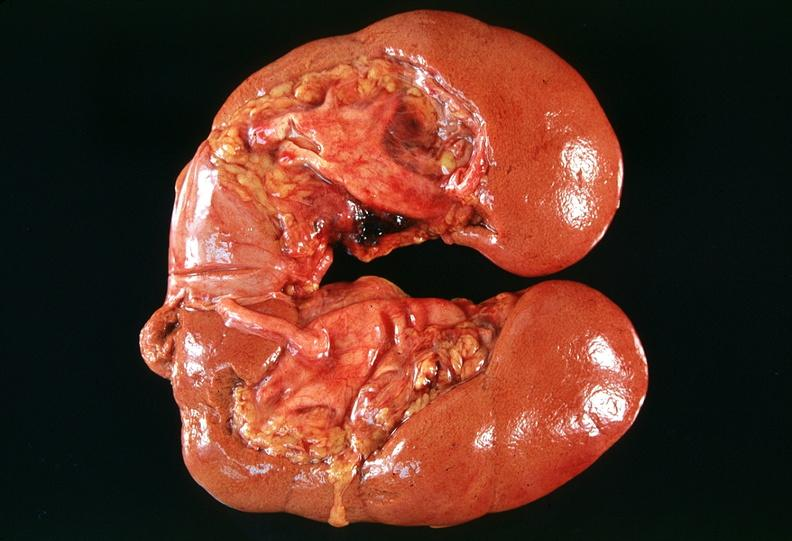what does this image show?
Answer the question using a single word or phrase. Horseshoe kidney in an adult 